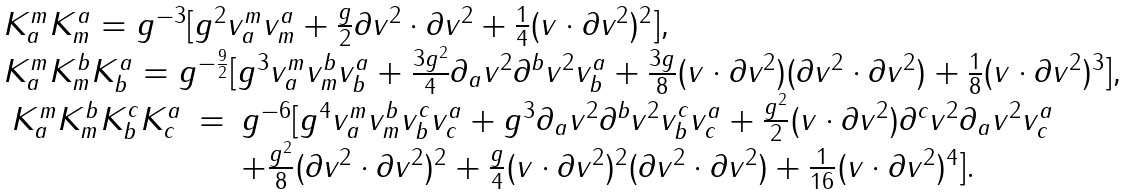Convert formula to latex. <formula><loc_0><loc_0><loc_500><loc_500>\begin{array} { c c l } & & K ^ { m } _ { a } K ^ { a } _ { m } = g ^ { - 3 } [ g ^ { 2 } v ^ { m } _ { a } v ^ { a } _ { m } + \frac { g } { 2 } \partial v ^ { 2 } \cdot \partial v ^ { 2 } + \frac { 1 } { 4 } ( v \cdot \partial v ^ { 2 } ) ^ { 2 } ] , \\ & & K ^ { m } _ { a } K ^ { b } _ { m } K ^ { a } _ { b } = g ^ { - \frac { 9 } { 2 } } [ g ^ { 3 } v ^ { m } _ { a } v ^ { b } _ { m } v ^ { a } _ { b } + \frac { 3 g ^ { 2 } } { 4 } \partial _ { a } v ^ { 2 } \partial ^ { b } v ^ { 2 } v ^ { a } _ { b } + \frac { 3 g } { 8 } ( v \cdot \partial v ^ { 2 } ) ( \partial v ^ { 2 } \cdot \partial v ^ { 2 } ) + \frac { 1 } { 8 } ( v \cdot \partial v ^ { 2 } ) ^ { 3 } ] , \\ & & \begin{array} { c c l } K ^ { m } _ { a } K ^ { b } _ { m } K ^ { c } _ { b } K ^ { a } _ { c } & = & g ^ { - 6 } [ g ^ { 4 } v ^ { m } _ { a } v ^ { b } _ { m } v ^ { c } _ { b } v ^ { a } _ { c } + g ^ { 3 } \partial _ { a } v ^ { 2 } \partial ^ { b } v ^ { 2 } v ^ { c } _ { b } v ^ { a } _ { c } + \frac { g ^ { 2 } } { 2 } ( v \cdot \partial v ^ { 2 } ) \partial ^ { c } v ^ { 2 } \partial _ { a } v ^ { 2 } v ^ { a } _ { c } \\ & & + \frac { g ^ { 2 } } { 8 } ( \partial v ^ { 2 } \cdot \partial v ^ { 2 } ) ^ { 2 } + \frac { g } { 4 } ( v \cdot \partial v ^ { 2 } ) ^ { 2 } ( \partial v ^ { 2 } \cdot \partial v ^ { 2 } ) + \frac { 1 } { 1 6 } ( v \cdot \partial v ^ { 2 } ) ^ { 4 } ] . \end{array} \end{array}</formula> 